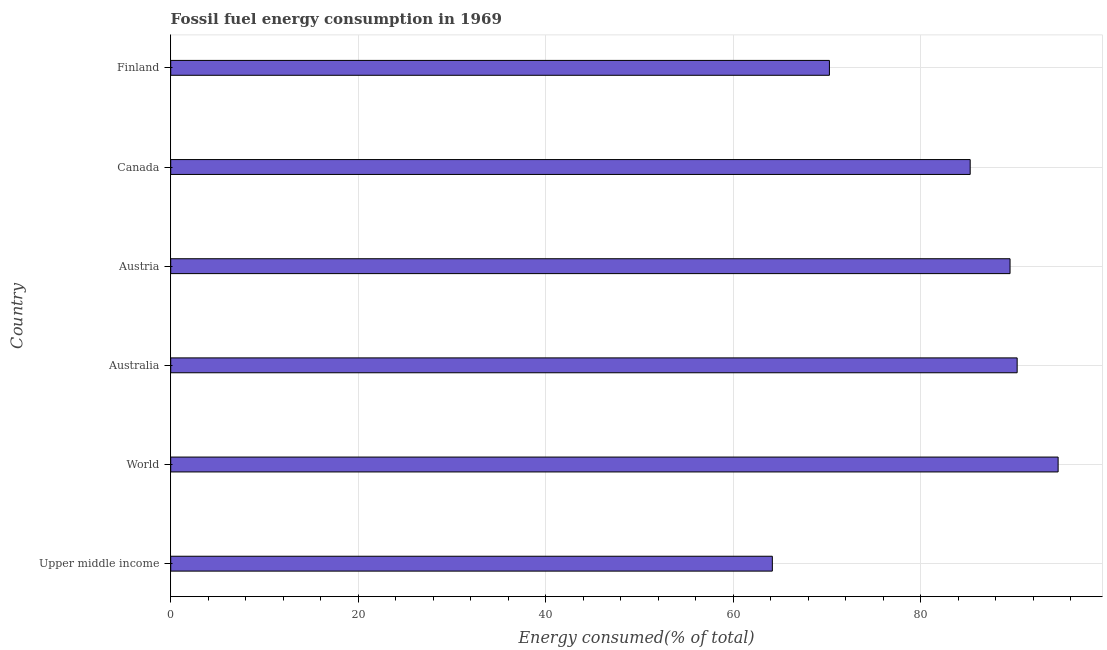Does the graph contain grids?
Keep it short and to the point. Yes. What is the title of the graph?
Keep it short and to the point. Fossil fuel energy consumption in 1969. What is the label or title of the X-axis?
Your response must be concise. Energy consumed(% of total). What is the fossil fuel energy consumption in Australia?
Provide a succinct answer. 90.27. Across all countries, what is the maximum fossil fuel energy consumption?
Your answer should be very brief. 94.64. Across all countries, what is the minimum fossil fuel energy consumption?
Your response must be concise. 64.16. In which country was the fossil fuel energy consumption maximum?
Your answer should be very brief. World. In which country was the fossil fuel energy consumption minimum?
Your answer should be very brief. Upper middle income. What is the sum of the fossil fuel energy consumption?
Your answer should be compact. 494.09. What is the difference between the fossil fuel energy consumption in Australia and Upper middle income?
Your response must be concise. 26.11. What is the average fossil fuel energy consumption per country?
Provide a short and direct response. 82.35. What is the median fossil fuel energy consumption?
Provide a succinct answer. 87.39. In how many countries, is the fossil fuel energy consumption greater than 4 %?
Your answer should be compact. 6. What is the ratio of the fossil fuel energy consumption in Australia to that in Upper middle income?
Offer a very short reply. 1.41. What is the difference between the highest and the second highest fossil fuel energy consumption?
Provide a short and direct response. 4.37. What is the difference between the highest and the lowest fossil fuel energy consumption?
Offer a terse response. 30.48. How many bars are there?
Ensure brevity in your answer.  6. What is the difference between two consecutive major ticks on the X-axis?
Offer a very short reply. 20. Are the values on the major ticks of X-axis written in scientific E-notation?
Provide a short and direct response. No. What is the Energy consumed(% of total) of Upper middle income?
Ensure brevity in your answer.  64.16. What is the Energy consumed(% of total) in World?
Your answer should be compact. 94.64. What is the Energy consumed(% of total) in Australia?
Your answer should be very brief. 90.27. What is the Energy consumed(% of total) of Austria?
Offer a very short reply. 89.51. What is the Energy consumed(% of total) of Canada?
Offer a very short reply. 85.26. What is the Energy consumed(% of total) in Finland?
Offer a terse response. 70.25. What is the difference between the Energy consumed(% of total) in Upper middle income and World?
Your answer should be very brief. -30.48. What is the difference between the Energy consumed(% of total) in Upper middle income and Australia?
Your response must be concise. -26.11. What is the difference between the Energy consumed(% of total) in Upper middle income and Austria?
Ensure brevity in your answer.  -25.35. What is the difference between the Energy consumed(% of total) in Upper middle income and Canada?
Make the answer very short. -21.1. What is the difference between the Energy consumed(% of total) in Upper middle income and Finland?
Offer a very short reply. -6.09. What is the difference between the Energy consumed(% of total) in World and Australia?
Offer a terse response. 4.37. What is the difference between the Energy consumed(% of total) in World and Austria?
Make the answer very short. 5.13. What is the difference between the Energy consumed(% of total) in World and Canada?
Your answer should be compact. 9.38. What is the difference between the Energy consumed(% of total) in World and Finland?
Offer a very short reply. 24.39. What is the difference between the Energy consumed(% of total) in Australia and Austria?
Make the answer very short. 0.76. What is the difference between the Energy consumed(% of total) in Australia and Canada?
Your answer should be compact. 5.01. What is the difference between the Energy consumed(% of total) in Australia and Finland?
Keep it short and to the point. 20.02. What is the difference between the Energy consumed(% of total) in Austria and Canada?
Offer a terse response. 4.25. What is the difference between the Energy consumed(% of total) in Austria and Finland?
Give a very brief answer. 19.26. What is the difference between the Energy consumed(% of total) in Canada and Finland?
Your answer should be compact. 15.01. What is the ratio of the Energy consumed(% of total) in Upper middle income to that in World?
Make the answer very short. 0.68. What is the ratio of the Energy consumed(% of total) in Upper middle income to that in Australia?
Make the answer very short. 0.71. What is the ratio of the Energy consumed(% of total) in Upper middle income to that in Austria?
Offer a terse response. 0.72. What is the ratio of the Energy consumed(% of total) in Upper middle income to that in Canada?
Ensure brevity in your answer.  0.75. What is the ratio of the Energy consumed(% of total) in Upper middle income to that in Finland?
Offer a terse response. 0.91. What is the ratio of the Energy consumed(% of total) in World to that in Australia?
Your answer should be compact. 1.05. What is the ratio of the Energy consumed(% of total) in World to that in Austria?
Ensure brevity in your answer.  1.06. What is the ratio of the Energy consumed(% of total) in World to that in Canada?
Ensure brevity in your answer.  1.11. What is the ratio of the Energy consumed(% of total) in World to that in Finland?
Provide a short and direct response. 1.35. What is the ratio of the Energy consumed(% of total) in Australia to that in Canada?
Your answer should be compact. 1.06. What is the ratio of the Energy consumed(% of total) in Australia to that in Finland?
Offer a very short reply. 1.28. What is the ratio of the Energy consumed(% of total) in Austria to that in Canada?
Provide a short and direct response. 1.05. What is the ratio of the Energy consumed(% of total) in Austria to that in Finland?
Offer a terse response. 1.27. What is the ratio of the Energy consumed(% of total) in Canada to that in Finland?
Your answer should be compact. 1.21. 